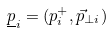<formula> <loc_0><loc_0><loc_500><loc_500>\underline { p } _ { i } = ( p _ { i } ^ { + } , \vec { p } _ { \perp i } )</formula> 